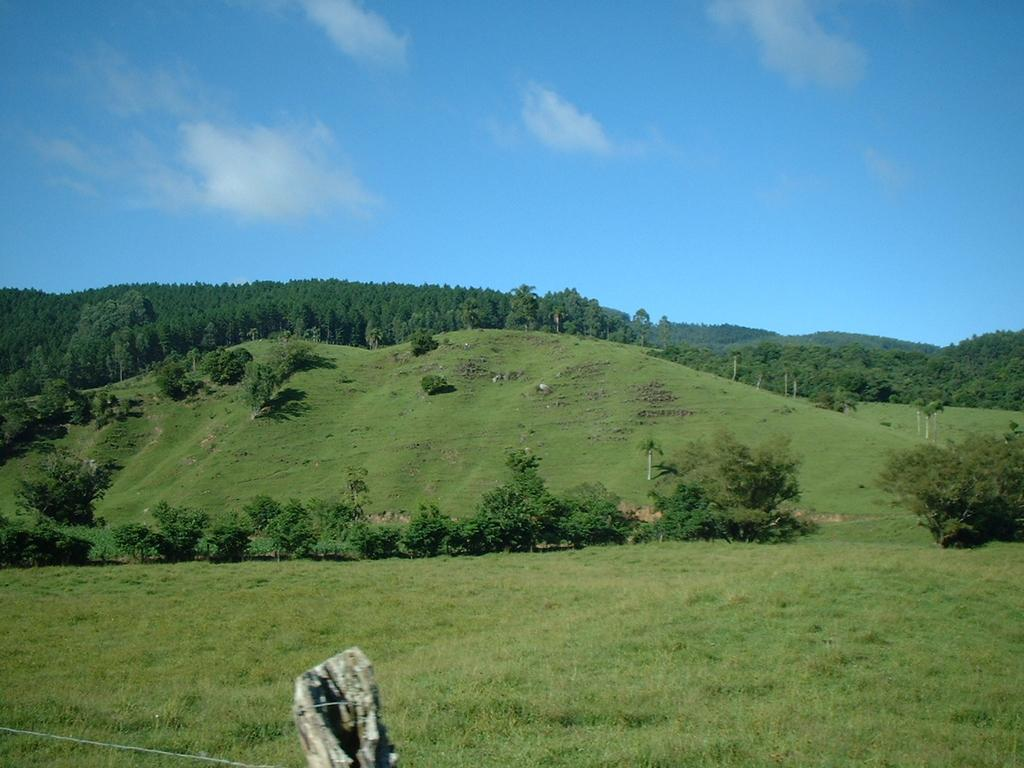What type of natural scenery is depicted in the picture? There is a natural scenery of green grass and trees in the picture. Can you describe any man-made structures in the image? There is a metal wire fence on the bottom left side of the picture. What can be seen in the sky in the image? There are clouds in the sky. How far away is the drawer from the trees in the image? There is no drawer present in the image. Can you describe the kicking motion of the person in the image? There is no person or kicking motion present in the image. 